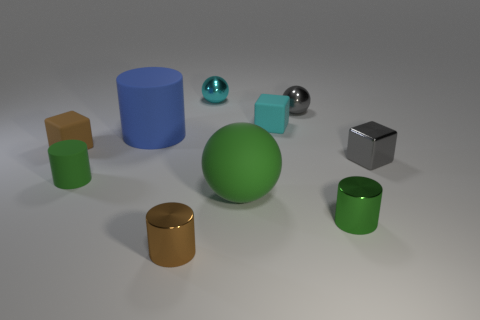Are there any gray metal blocks that are behind the small gray object in front of the cyan cube?
Make the answer very short. No. Are there any cyan metallic things?
Your response must be concise. Yes. What color is the cylinder behind the matte block in front of the blue rubber object?
Offer a terse response. Blue. There is a blue thing that is the same shape as the tiny green metal object; what material is it?
Provide a short and direct response. Rubber. How many green things are the same size as the brown cylinder?
Ensure brevity in your answer.  2. There is a cube that is made of the same material as the tiny gray ball; what is its size?
Provide a short and direct response. Small. What number of other small metallic things are the same shape as the small brown metallic thing?
Make the answer very short. 1. What number of small brown matte things are there?
Offer a very short reply. 1. There is a gray thing in front of the big blue matte cylinder; is it the same shape as the small brown matte object?
Make the answer very short. Yes. What is the material of the gray cube that is the same size as the green rubber cylinder?
Make the answer very short. Metal. 